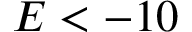Convert formula to latex. <formula><loc_0><loc_0><loc_500><loc_500>E < - 1 0</formula> 